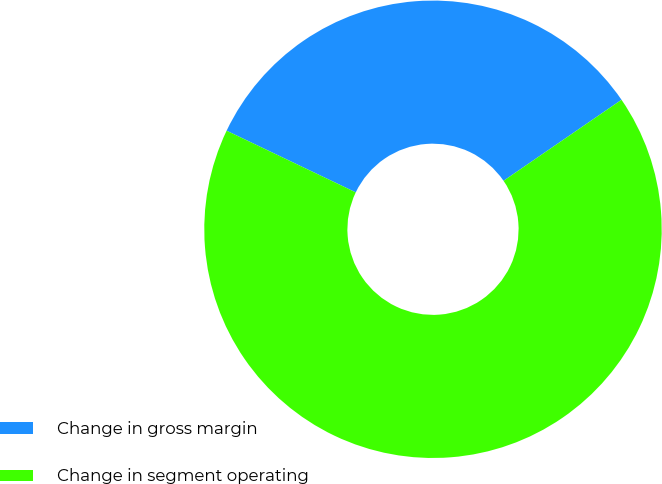Convert chart. <chart><loc_0><loc_0><loc_500><loc_500><pie_chart><fcel>Change in gross margin<fcel>Change in segment operating<nl><fcel>33.33%<fcel>66.67%<nl></chart> 